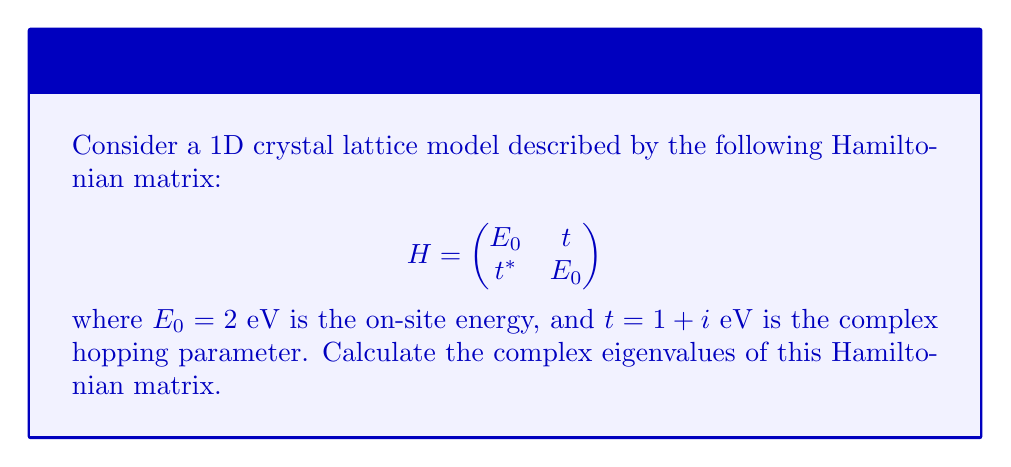Can you solve this math problem? To find the complex eigenvalues of the Hamiltonian matrix, we'll follow these steps:

1) The characteristic equation for eigenvalues λ is:
   $$\det(H - λI) = 0$$

2) Expanding the determinant:
   $$\begin{vmatrix}
   E_0 - λ & t \\
   t^* & E_0 - λ
   \end{vmatrix} = 0$$

3) This gives us:
   $$(E_0 - λ)^2 - |t|^2 = 0$$

4) Substituting the given values:
   $$(2 - λ)^2 - |(1 + i)|^2 = 0$$

5) Simplify:
   $$(2 - λ)^2 - (1^2 + 1^2) = 0$$
   $$(2 - λ)^2 - 2 = 0$$

6) Solve the quadratic equation:
   $(2 - λ)^2 = 2$
   $2 - λ = ±\sqrt{2}$

7) Therefore, the eigenvalues are:
   $λ = 2 ± \sqrt{2}$

These eigenvalues are real, which is expected for a Hermitian matrix (as our Hamiltonian is).
Answer: $λ_1 = 2 + \sqrt{2}$ eV, $λ_2 = 2 - \sqrt{2}$ eV 